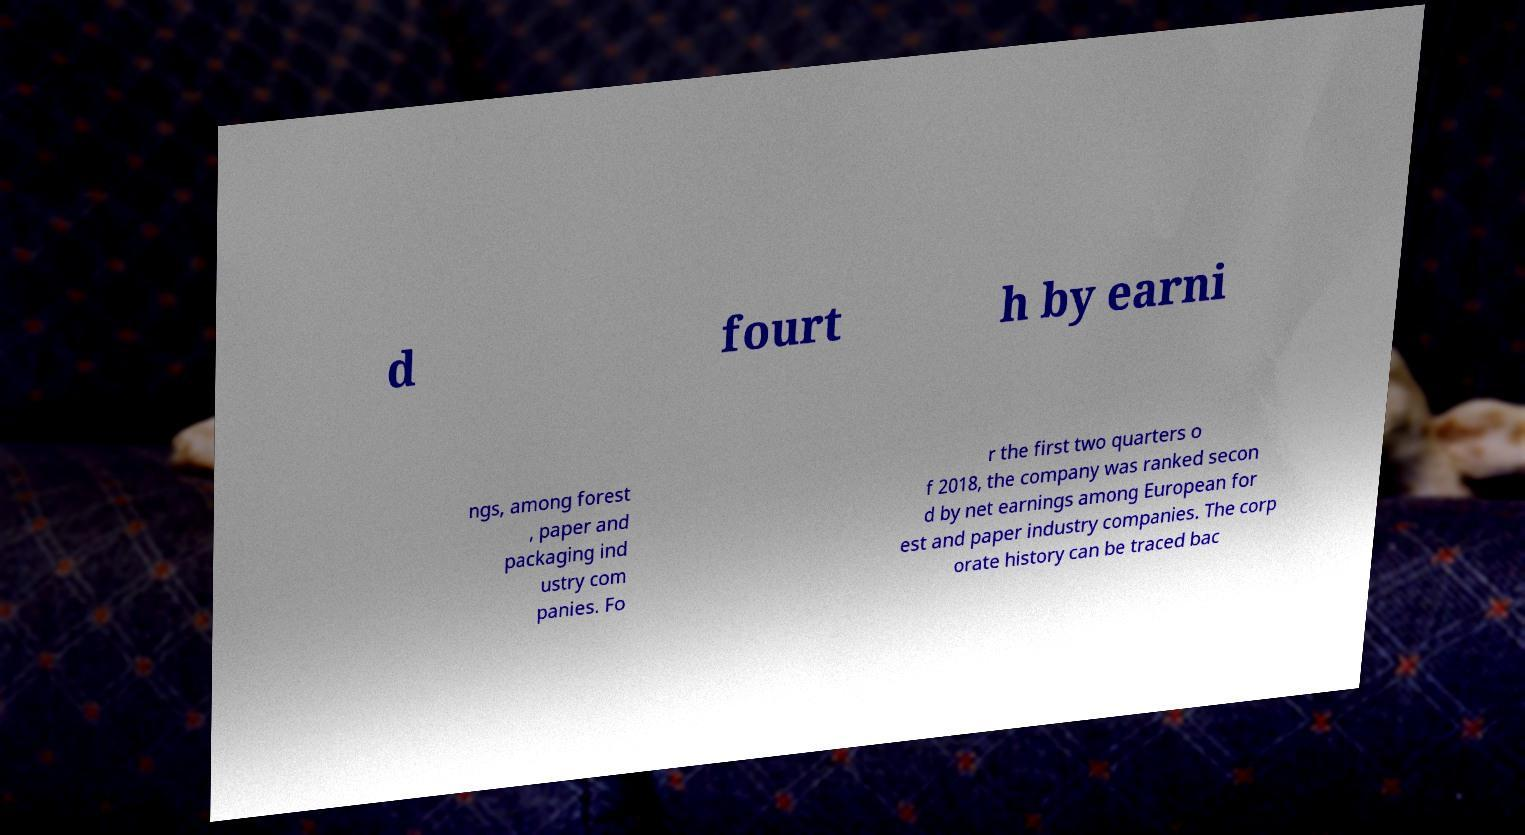For documentation purposes, I need the text within this image transcribed. Could you provide that? d fourt h by earni ngs, among forest , paper and packaging ind ustry com panies. Fo r the first two quarters o f 2018, the company was ranked secon d by net earnings among European for est and paper industry companies. The corp orate history can be traced bac 